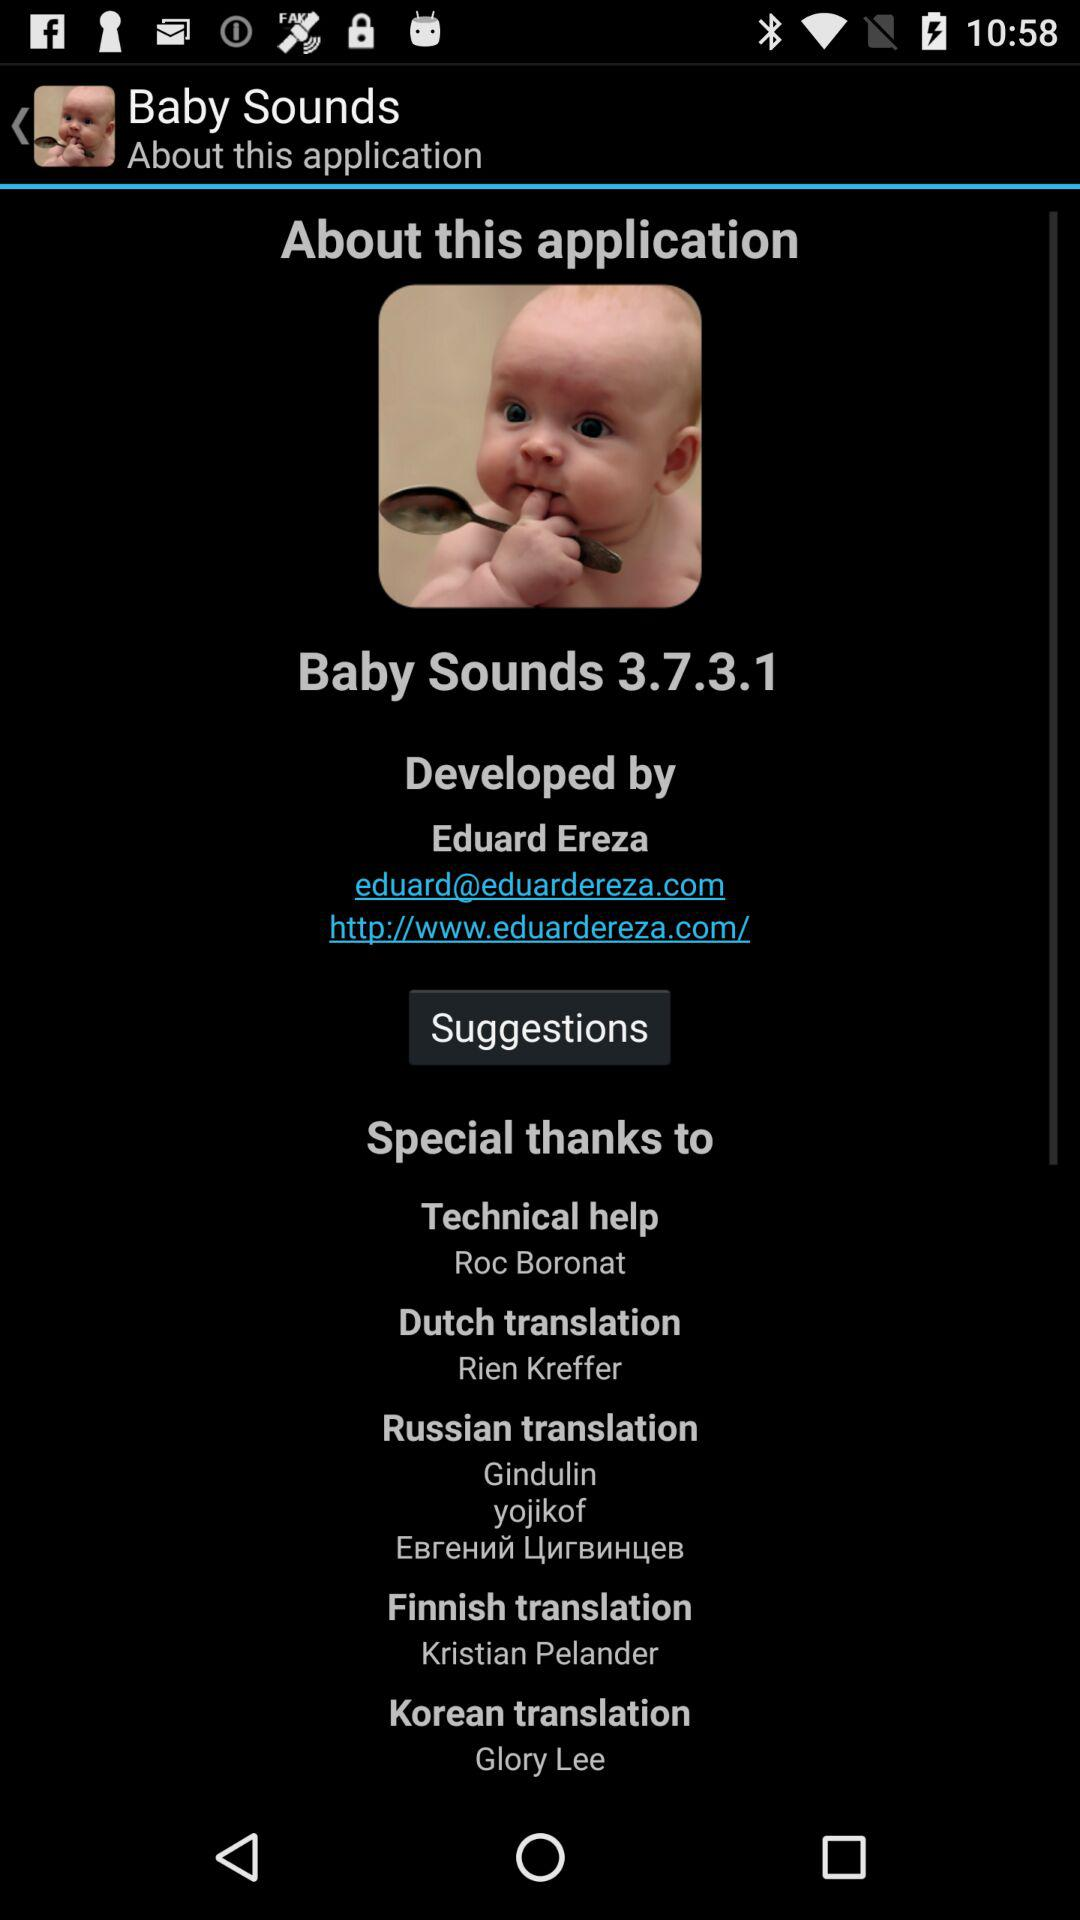Who is the developer of the "Baby Sounds" application? The developer of the "Baby Sounds" application is Eduard Ereza. 